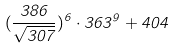Convert formula to latex. <formula><loc_0><loc_0><loc_500><loc_500>( \frac { 3 8 6 } { \sqrt { 3 0 7 } } ) ^ { 6 } \cdot 3 6 3 ^ { 9 } + 4 0 4</formula> 